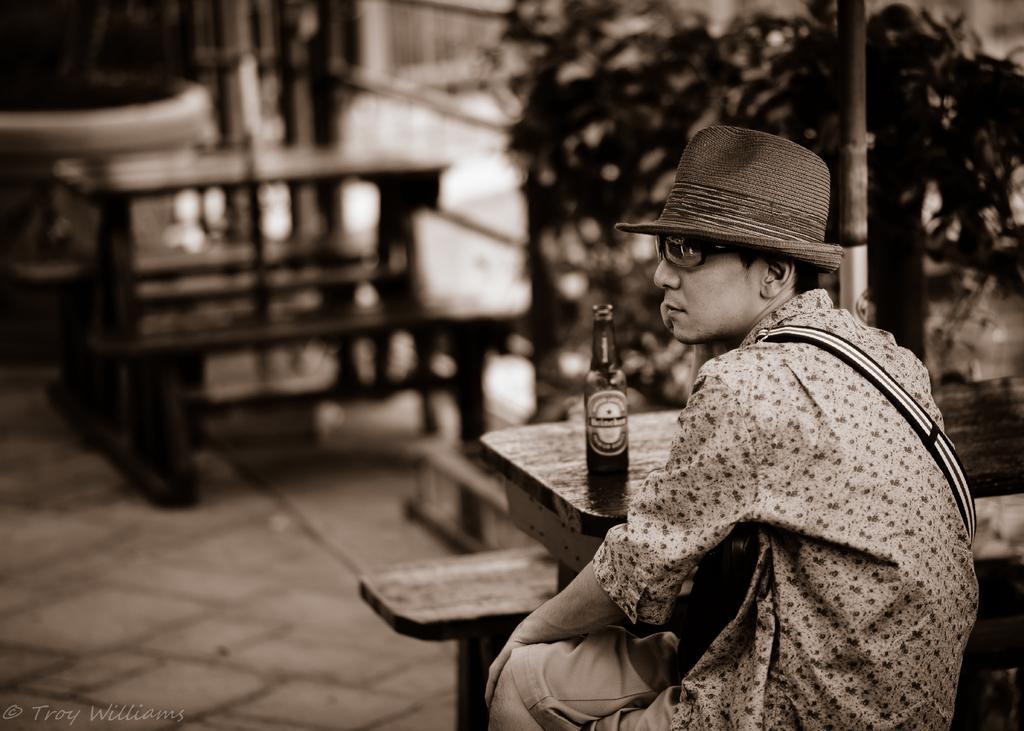Describe this image in one or two sentences. As we can see in the image there are trees, benches, a man sitting over here and on table there is a bottle. 